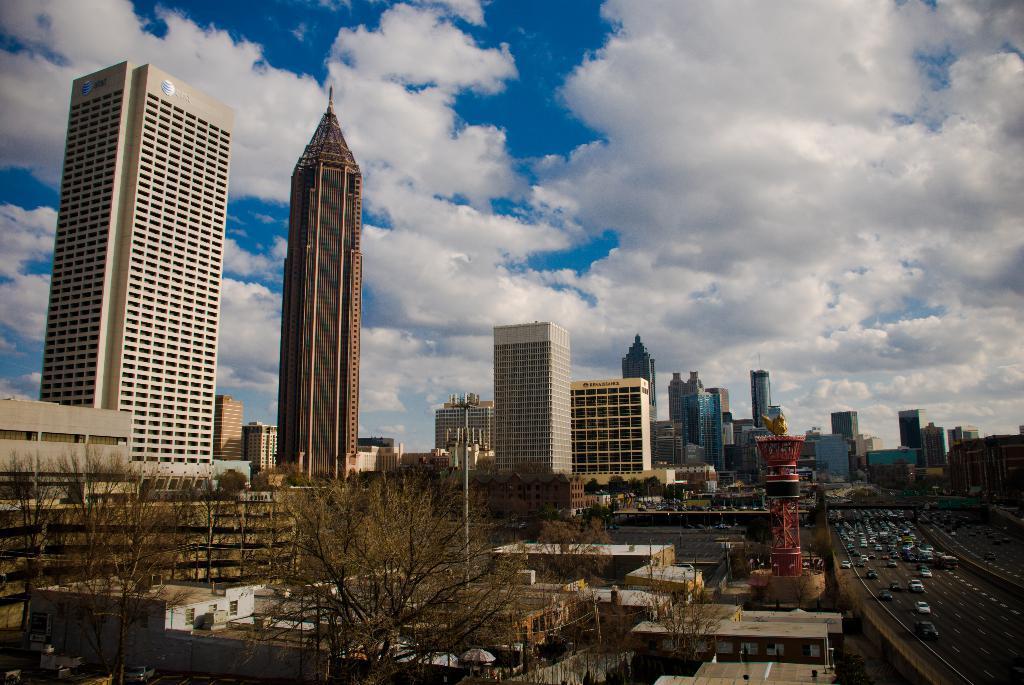In one or two sentences, can you explain what this image depicts? In the image in the center, we can see buildings, trees and a few vehicles on the road, etc. In the background we can see the sky and clouds. 